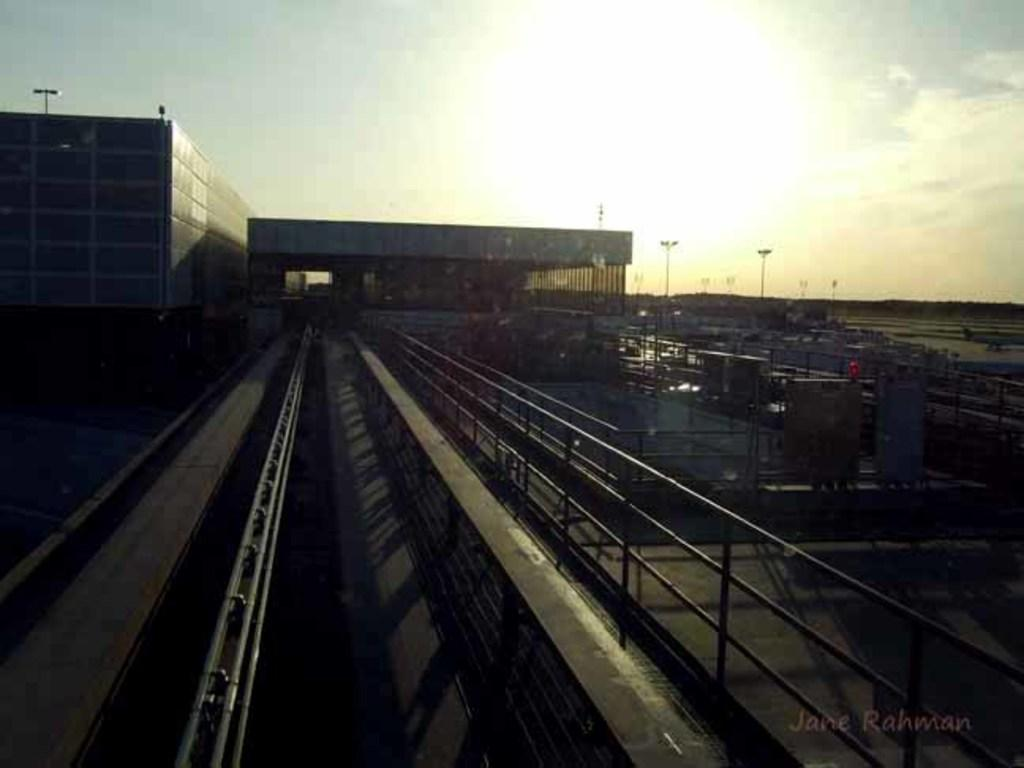What type of structures can be seen in the image? There are buildings in the image. What type of security or safety features are present in the image? Iron grills and railings are visible in the image. What type of vertical structures are present in the image? Poles are in the image. What type of lighting is present in the image? Street lights are present in the image. What part of the natural environment is visible in the image? The sky is visible in the image, and clouds are present in the sky. Can you see a ship sailing in the sky in the image? No, there is no ship present in the image. Is the queen visible in the image, waving to her subjects? No, the queen is not present in the image. 